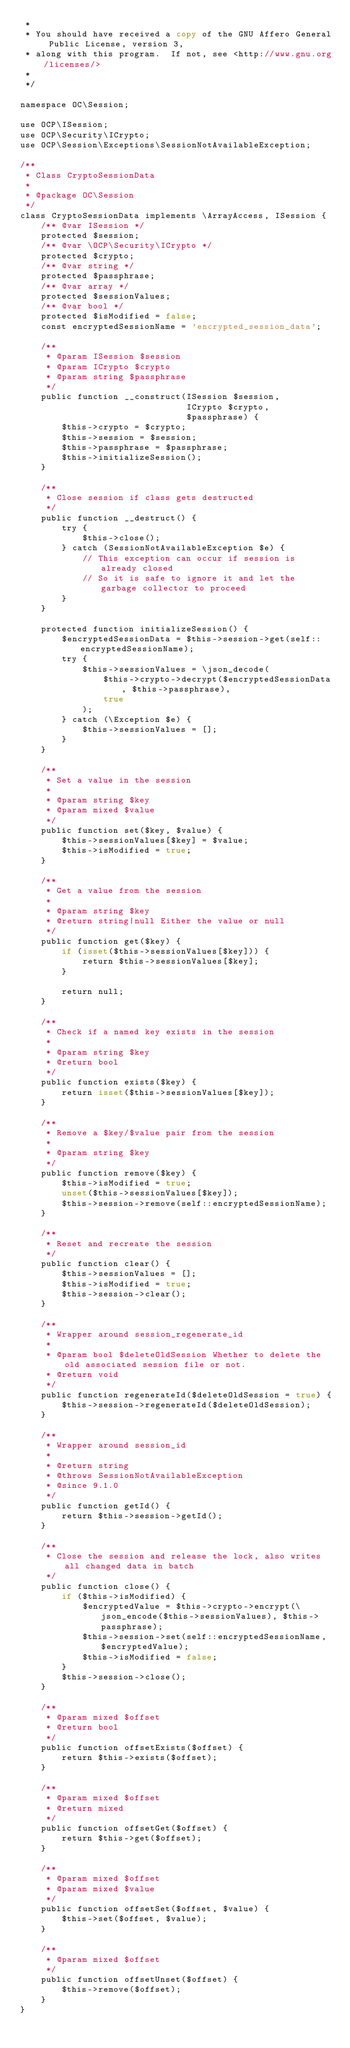Convert code to text. <code><loc_0><loc_0><loc_500><loc_500><_PHP_> *
 * You should have received a copy of the GNU Affero General Public License, version 3,
 * along with this program.  If not, see <http://www.gnu.org/licenses/>
 *
 */

namespace OC\Session;

use OCP\ISession;
use OCP\Security\ICrypto;
use OCP\Session\Exceptions\SessionNotAvailableException;

/**
 * Class CryptoSessionData
 *
 * @package OC\Session
 */
class CryptoSessionData implements \ArrayAccess, ISession {
	/** @var ISession */
	protected $session;
	/** @var \OCP\Security\ICrypto */
	protected $crypto;
	/** @var string */
	protected $passphrase;
	/** @var array */
	protected $sessionValues;
	/** @var bool */
	protected $isModified = false;
	const encryptedSessionName = 'encrypted_session_data';

	/**
	 * @param ISession $session
	 * @param ICrypto $crypto
	 * @param string $passphrase
	 */
	public function __construct(ISession $session,
								ICrypto $crypto,
								$passphrase) {
		$this->crypto = $crypto;
		$this->session = $session;
		$this->passphrase = $passphrase;
		$this->initializeSession();
	}

	/**
	 * Close session if class gets destructed
	 */
	public function __destruct() {
		try {
			$this->close();
		} catch (SessionNotAvailableException $e) {
			// This exception can occur if session is already closed
			// So it is safe to ignore it and let the garbage collector to proceed
		}
	}

	protected function initializeSession() {
		$encryptedSessionData = $this->session->get(self::encryptedSessionName);
		try {
			$this->sessionValues = \json_decode(
				$this->crypto->decrypt($encryptedSessionData, $this->passphrase),
				true
			);
		} catch (\Exception $e) {
			$this->sessionValues = [];
		}
	}

	/**
	 * Set a value in the session
	 *
	 * @param string $key
	 * @param mixed $value
	 */
	public function set($key, $value) {
		$this->sessionValues[$key] = $value;
		$this->isModified = true;
	}

	/**
	 * Get a value from the session
	 *
	 * @param string $key
	 * @return string|null Either the value or null
	 */
	public function get($key) {
		if (isset($this->sessionValues[$key])) {
			return $this->sessionValues[$key];
		}

		return null;
	}

	/**
	 * Check if a named key exists in the session
	 *
	 * @param string $key
	 * @return bool
	 */
	public function exists($key) {
		return isset($this->sessionValues[$key]);
	}

	/**
	 * Remove a $key/$value pair from the session
	 *
	 * @param string $key
	 */
	public function remove($key) {
		$this->isModified = true;
		unset($this->sessionValues[$key]);
		$this->session->remove(self::encryptedSessionName);
	}

	/**
	 * Reset and recreate the session
	 */
	public function clear() {
		$this->sessionValues = [];
		$this->isModified = true;
		$this->session->clear();
	}

	/**
	 * Wrapper around session_regenerate_id
	 *
	 * @param bool $deleteOldSession Whether to delete the old associated session file or not.
	 * @return void
	 */
	public function regenerateId($deleteOldSession = true) {
		$this->session->regenerateId($deleteOldSession);
	}

	/**
	 * Wrapper around session_id
	 *
	 * @return string
	 * @throws SessionNotAvailableException
	 * @since 9.1.0
	 */
	public function getId() {
		return $this->session->getId();
	}

	/**
	 * Close the session and release the lock, also writes all changed data in batch
	 */
	public function close() {
		if ($this->isModified) {
			$encryptedValue = $this->crypto->encrypt(\json_encode($this->sessionValues), $this->passphrase);
			$this->session->set(self::encryptedSessionName, $encryptedValue);
			$this->isModified = false;
		}
		$this->session->close();
	}

	/**
	 * @param mixed $offset
	 * @return bool
	 */
	public function offsetExists($offset) {
		return $this->exists($offset);
	}

	/**
	 * @param mixed $offset
	 * @return mixed
	 */
	public function offsetGet($offset) {
		return $this->get($offset);
	}

	/**
	 * @param mixed $offset
	 * @param mixed $value
	 */
	public function offsetSet($offset, $value) {
		$this->set($offset, $value);
	}

	/**
	 * @param mixed $offset
	 */
	public function offsetUnset($offset) {
		$this->remove($offset);
	}
}
</code> 